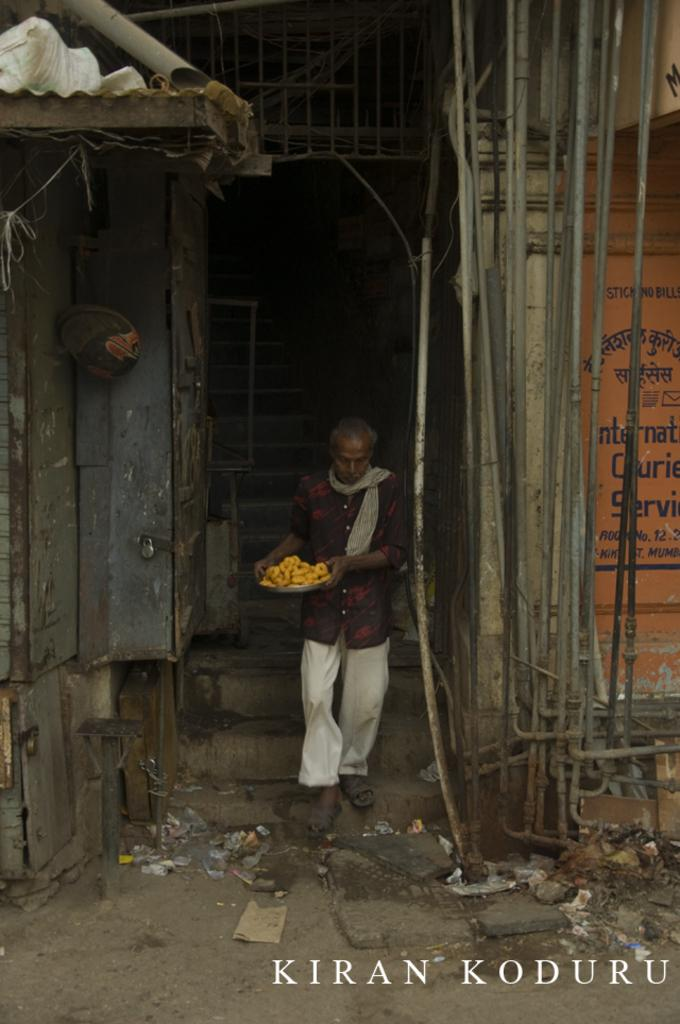What is the main subject of the image? There is a man in the image. What is the man holding in the image? The man is holding a plate in the image. What is the man doing in the image? The man is walking on a path in the image. What can be seen in the background of the image? There are steps, a wall, and pipes in the background of the image. Is there any indication of the image's origin or ownership? Yes, there is a watermark on the image. What direction is the trail leading in the image? There is no trail present in the image; it features a man walking on a path. How does the watermark move around in the image? The watermark does not move around in the image; it is a static element that provides information about the image's origin or ownership. 